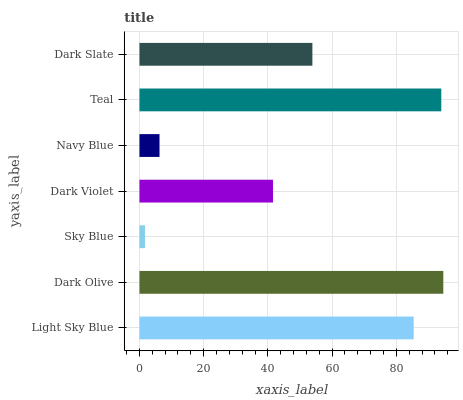Is Sky Blue the minimum?
Answer yes or no. Yes. Is Dark Olive the maximum?
Answer yes or no. Yes. Is Dark Olive the minimum?
Answer yes or no. No. Is Sky Blue the maximum?
Answer yes or no. No. Is Dark Olive greater than Sky Blue?
Answer yes or no. Yes. Is Sky Blue less than Dark Olive?
Answer yes or no. Yes. Is Sky Blue greater than Dark Olive?
Answer yes or no. No. Is Dark Olive less than Sky Blue?
Answer yes or no. No. Is Dark Slate the high median?
Answer yes or no. Yes. Is Dark Slate the low median?
Answer yes or no. Yes. Is Dark Olive the high median?
Answer yes or no. No. Is Teal the low median?
Answer yes or no. No. 